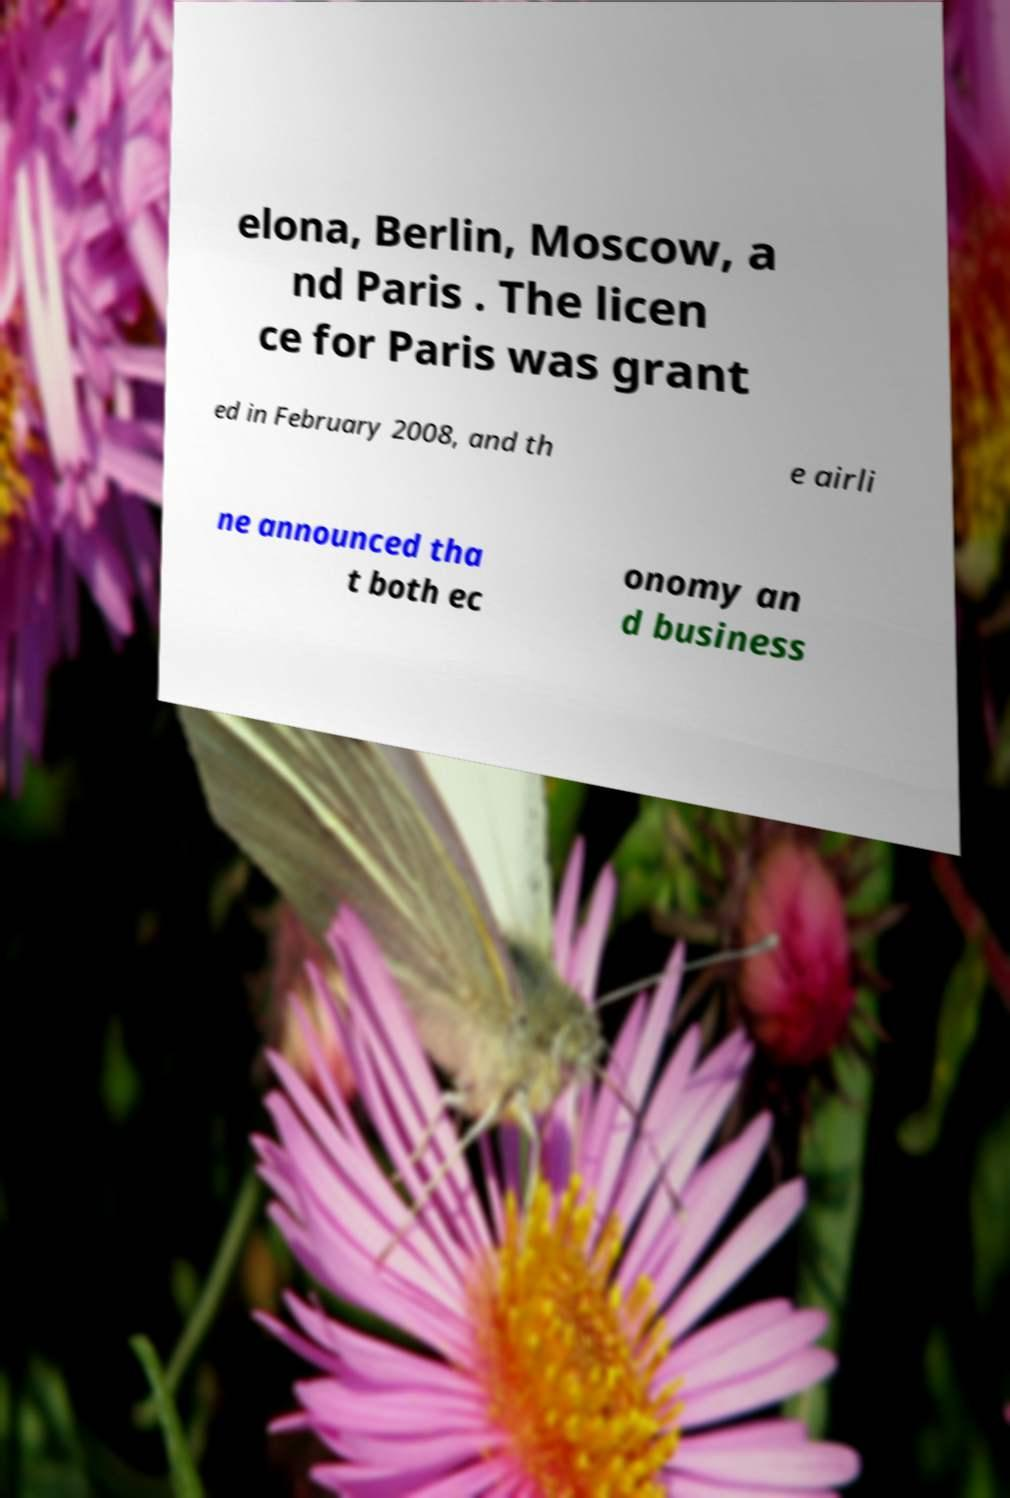Please identify and transcribe the text found in this image. elona, Berlin, Moscow, a nd Paris . The licen ce for Paris was grant ed in February 2008, and th e airli ne announced tha t both ec onomy an d business 